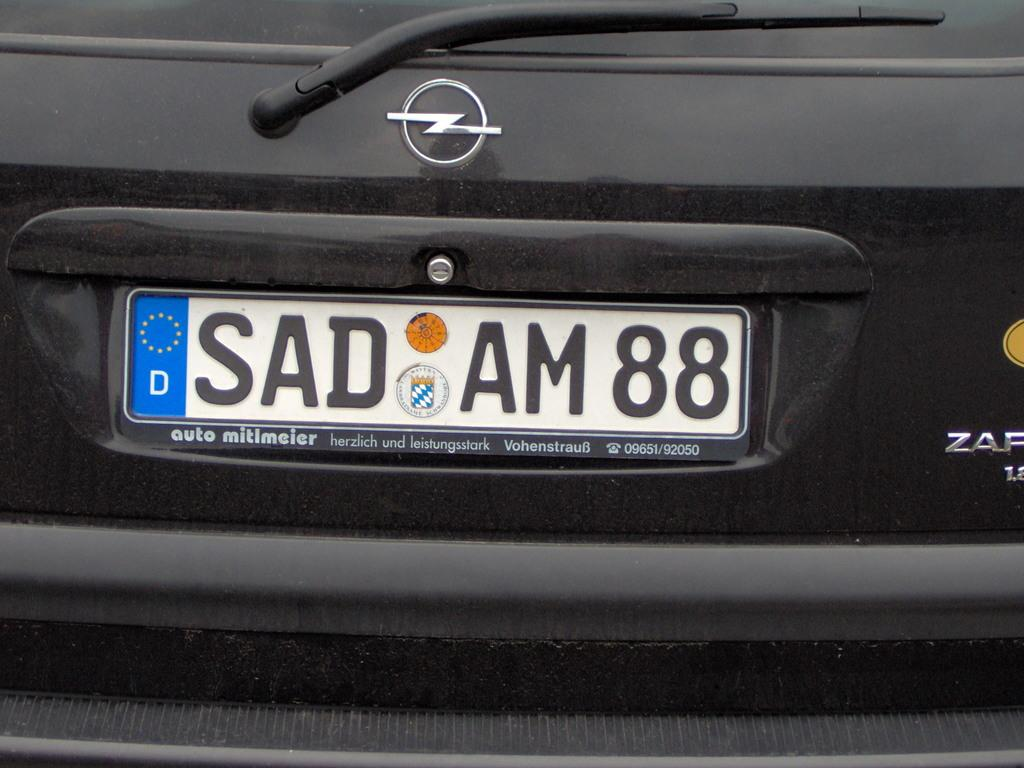<image>
Present a compact description of the photo's key features. A black car in Europe has the license plate number SAD AM8. 